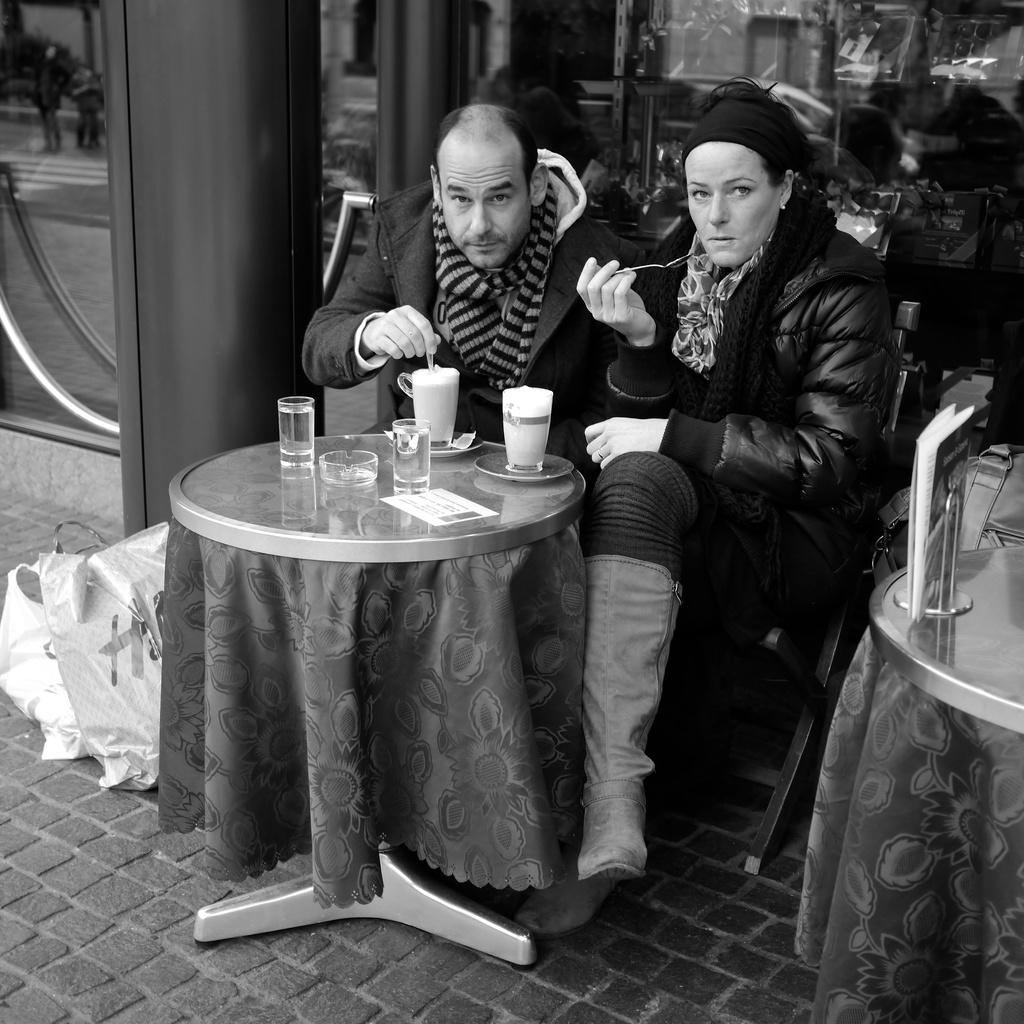How many people are in the image? There are two persons in the image. What are the two persons doing in the image? The two persons are sitting in a chair. What is in front of the two persons? There is a table in front of them. What can be seen on the table? There are glasses on the table. What type of balls are being juggled by the two persons in the image? There are no balls or juggling activity present in the image. 